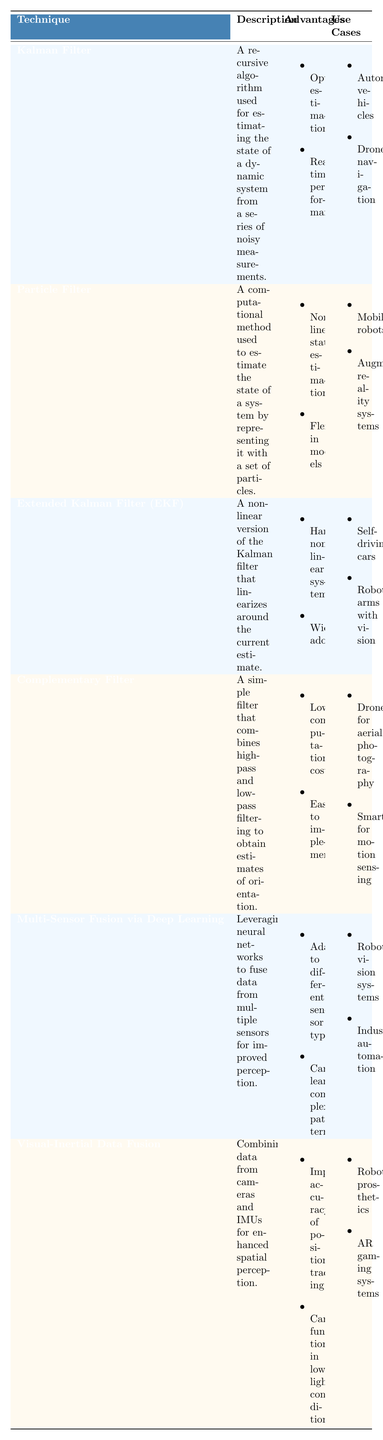What is the main advantage of using the Kalman Filter? The table lists two advantages of the Kalman Filter: optimal estimation and real-time performance. Therefore, its main advantage can be considered as optimal estimation.
Answer: Optimal estimation What applications are associated with Multi-Sensor Fusion via Deep Learning? From the table, the applications listed for Multi-Sensor Fusion via Deep Learning are object recognition with LIDAR and cameras and scene understanding.
Answer: Object recognition with LIDAR and cameras, scene understanding Is the Complementary Filter suitable for low computational use? The table states that the Complementary Filter has low computational cost, indicating that it is indeed suitable for low computational use.
Answer: Yes How many techniques listed require careful tuning? The table indicates that the Particle Filter requires careful tuning, and there is no mention of other techniques needing this. Hence, only one technique requires careful tuning.
Answer: 1 Which sensor fusion technique is known for its non-linear state estimation? The Particle Filter is explicitly mentioned in the table to have non-linear state estimation as one of its advantages.
Answer: Particle Filter Do any of the listed techniques utilize neural networks? The table shows that Multi-Sensor Fusion via Deep Learning is the only technique that leverages neural networks for sensor fusion.
Answer: Yes What advantages does fusing Visual-Inertial Data provide? According to the table, fusing Visual-Inertial Data improves the accuracy of position tracking and can operate in low-light conditions.
Answer: Improves accuracy of position tracking, functions in low-light Which technique has the broadest application range? The techniques can be grouped by their applications: for instance, the Extended Kalman Filter (EKF) is listed for both self-driving cars and robotic arms with vision. By examining all applications listed, Extended Kalman Filter (EKF) can be considered to have a broad application range due to its use in multiple domains.
Answer: Extended Kalman Filter (EKF) What are the primary disadvantages of using a Particle Filter? The table outlines two disadvantages of using the Particle Filter: it is computationally intensive and requires careful tuning.
Answer: Computationally intensive, requires careful tuning Which technique is better suited for applications needing low-cost implementation? The Complementary Filter, as noted in the table, has a low computational cost and is easy to implement, making it better suited for low-cost applications.
Answer: Complementary Filter 